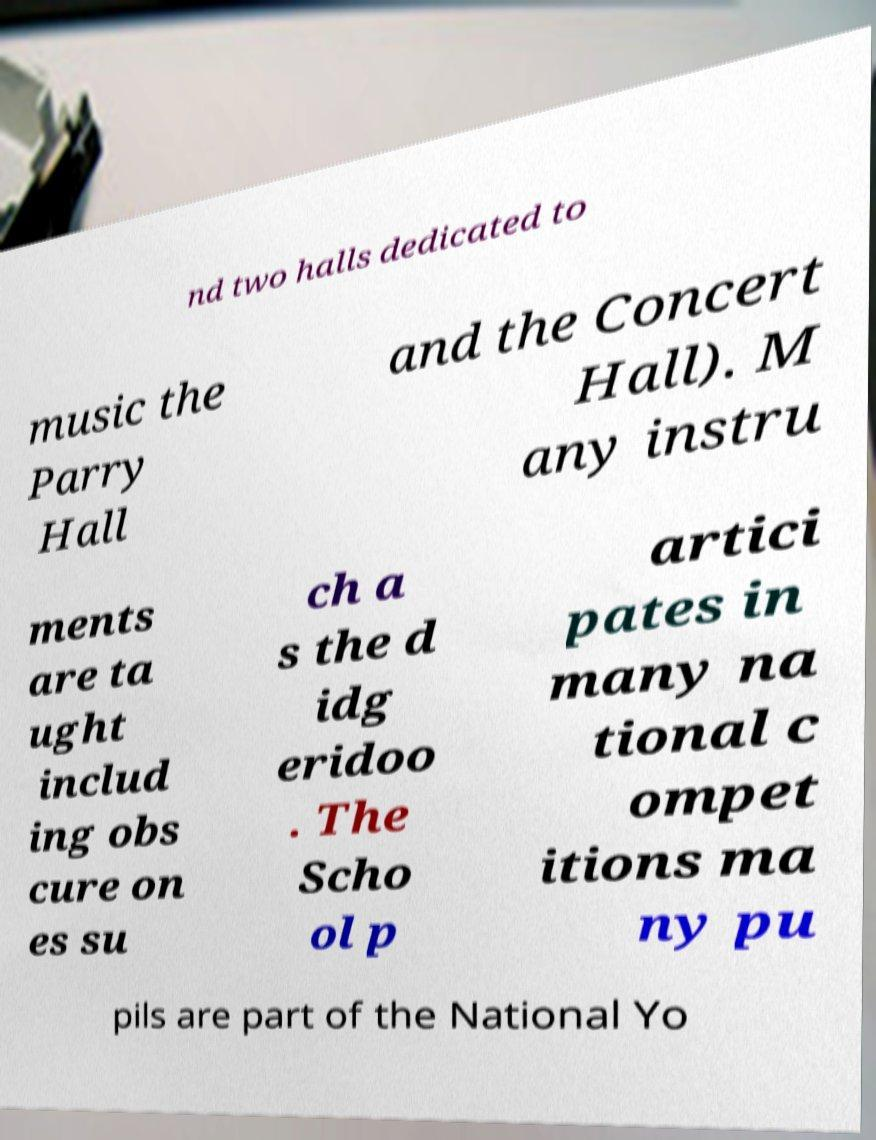Could you assist in decoding the text presented in this image and type it out clearly? nd two halls dedicated to music the Parry Hall and the Concert Hall). M any instru ments are ta ught includ ing obs cure on es su ch a s the d idg eridoo . The Scho ol p artici pates in many na tional c ompet itions ma ny pu pils are part of the National Yo 